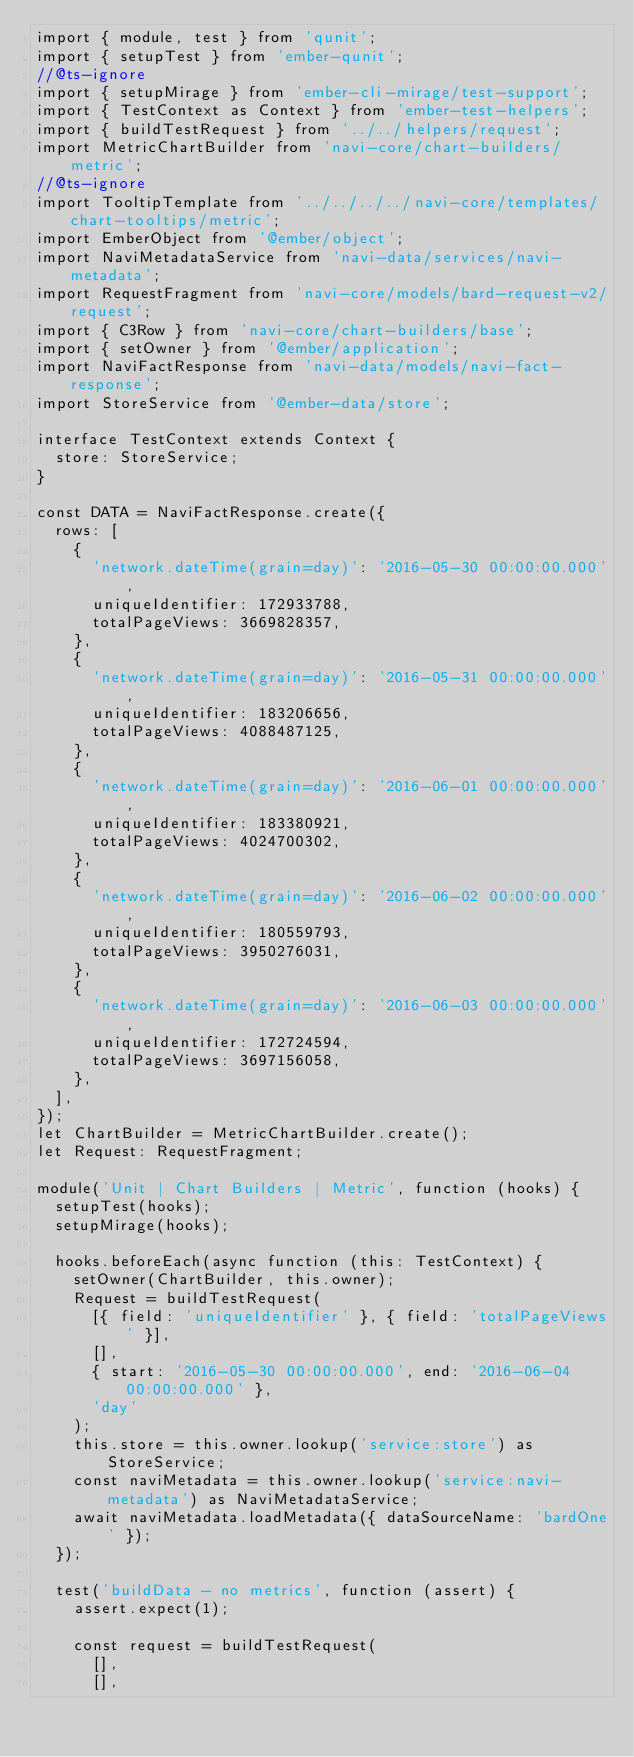Convert code to text. <code><loc_0><loc_0><loc_500><loc_500><_TypeScript_>import { module, test } from 'qunit';
import { setupTest } from 'ember-qunit';
//@ts-ignore
import { setupMirage } from 'ember-cli-mirage/test-support';
import { TestContext as Context } from 'ember-test-helpers';
import { buildTestRequest } from '../../helpers/request';
import MetricChartBuilder from 'navi-core/chart-builders/metric';
//@ts-ignore
import TooltipTemplate from '../../../../navi-core/templates/chart-tooltips/metric';
import EmberObject from '@ember/object';
import NaviMetadataService from 'navi-data/services/navi-metadata';
import RequestFragment from 'navi-core/models/bard-request-v2/request';
import { C3Row } from 'navi-core/chart-builders/base';
import { setOwner } from '@ember/application';
import NaviFactResponse from 'navi-data/models/navi-fact-response';
import StoreService from '@ember-data/store';

interface TestContext extends Context {
  store: StoreService;
}

const DATA = NaviFactResponse.create({
  rows: [
    {
      'network.dateTime(grain=day)': '2016-05-30 00:00:00.000',
      uniqueIdentifier: 172933788,
      totalPageViews: 3669828357,
    },
    {
      'network.dateTime(grain=day)': '2016-05-31 00:00:00.000',
      uniqueIdentifier: 183206656,
      totalPageViews: 4088487125,
    },
    {
      'network.dateTime(grain=day)': '2016-06-01 00:00:00.000',
      uniqueIdentifier: 183380921,
      totalPageViews: 4024700302,
    },
    {
      'network.dateTime(grain=day)': '2016-06-02 00:00:00.000',
      uniqueIdentifier: 180559793,
      totalPageViews: 3950276031,
    },
    {
      'network.dateTime(grain=day)': '2016-06-03 00:00:00.000',
      uniqueIdentifier: 172724594,
      totalPageViews: 3697156058,
    },
  ],
});
let ChartBuilder = MetricChartBuilder.create();
let Request: RequestFragment;

module('Unit | Chart Builders | Metric', function (hooks) {
  setupTest(hooks);
  setupMirage(hooks);

  hooks.beforeEach(async function (this: TestContext) {
    setOwner(ChartBuilder, this.owner);
    Request = buildTestRequest(
      [{ field: 'uniqueIdentifier' }, { field: 'totalPageViews' }],
      [],
      { start: '2016-05-30 00:00:00.000', end: '2016-06-04 00:00:00.000' },
      'day'
    );
    this.store = this.owner.lookup('service:store') as StoreService;
    const naviMetadata = this.owner.lookup('service:navi-metadata') as NaviMetadataService;
    await naviMetadata.loadMetadata({ dataSourceName: 'bardOne' });
  });

  test('buildData - no metrics', function (assert) {
    assert.expect(1);

    const request = buildTestRequest(
      [],
      [],</code> 